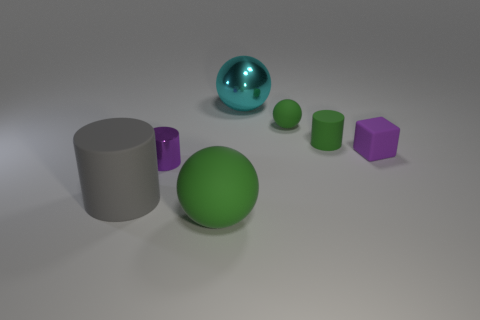Is there a tiny cyan metal object that has the same shape as the large gray rubber object?
Offer a terse response. No. There is a rubber ball that is in front of the metallic object in front of the purple block on the right side of the large rubber cylinder; how big is it?
Provide a succinct answer. Large. Are there the same number of purple matte blocks behind the tiny purple metal cylinder and big matte objects to the right of the cyan object?
Provide a short and direct response. No. The gray thing that is made of the same material as the block is what size?
Provide a short and direct response. Large. The small rubber ball is what color?
Provide a succinct answer. Green. What number of rubber cubes have the same color as the metallic cylinder?
Your response must be concise. 1. There is a cylinder that is the same size as the cyan metal thing; what is its material?
Offer a terse response. Rubber. Is there a cyan thing in front of the big sphere in front of the big cylinder?
Make the answer very short. No. How many other things are the same color as the large metal ball?
Provide a succinct answer. 0. The cyan thing is what size?
Give a very brief answer. Large. 